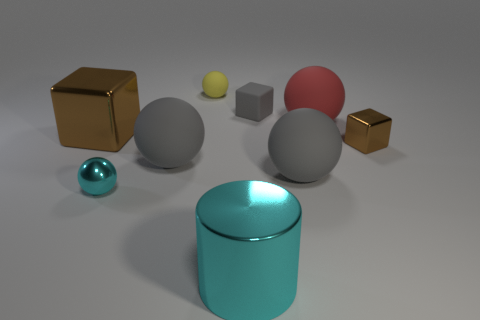How many objects are brown metal objects or metallic cubes that are on the left side of the small cyan shiny object?
Your answer should be very brief. 2. Is there a tiny gray cube that is left of the brown metal thing on the left side of the cyan sphere?
Your answer should be compact. No. The brown object behind the tiny metal thing that is behind the large gray ball that is right of the metal cylinder is what shape?
Provide a short and direct response. Cube. What is the color of the large thing that is both in front of the tiny brown object and right of the tiny gray matte cube?
Give a very brief answer. Gray. There is a brown thing that is right of the small rubber block; what is its shape?
Make the answer very short. Cube. There is a large brown thing that is the same material as the tiny cyan object; what shape is it?
Provide a succinct answer. Cube. What number of rubber objects are either brown objects or large spheres?
Provide a short and direct response. 3. There is a cyan shiny thing that is behind the big shiny thing that is in front of the big metallic block; what number of spheres are behind it?
Provide a short and direct response. 4. Do the gray ball to the left of the small gray thing and the shiny cube in front of the large brown block have the same size?
Ensure brevity in your answer.  No. What material is the small brown thing that is the same shape as the small gray object?
Provide a short and direct response. Metal. 